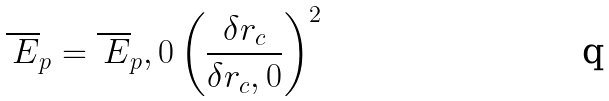<formula> <loc_0><loc_0><loc_500><loc_500>\overline { \, E } _ { p } = \overline { \, E } _ { p } , 0 \left ( \frac { \delta r _ { c } } { \delta r _ { c } , 0 } \right ) ^ { 2 } \,</formula> 